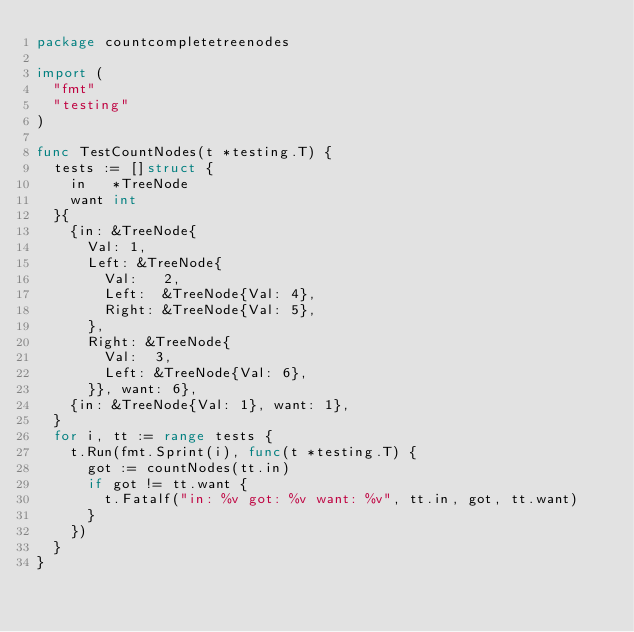<code> <loc_0><loc_0><loc_500><loc_500><_Go_>package countcompletetreenodes

import (
	"fmt"
	"testing"
)

func TestCountNodes(t *testing.T) {
	tests := []struct {
		in   *TreeNode
		want int
	}{
		{in: &TreeNode{
			Val: 1,
			Left: &TreeNode{
				Val:   2,
				Left:  &TreeNode{Val: 4},
				Right: &TreeNode{Val: 5},
			},
			Right: &TreeNode{
				Val:  3,
				Left: &TreeNode{Val: 6},
			}}, want: 6},
		{in: &TreeNode{Val: 1}, want: 1},
	}
	for i, tt := range tests {
		t.Run(fmt.Sprint(i), func(t *testing.T) {
			got := countNodes(tt.in)
			if got != tt.want {
				t.Fatalf("in: %v got: %v want: %v", tt.in, got, tt.want)
			}
		})
	}
}
</code> 